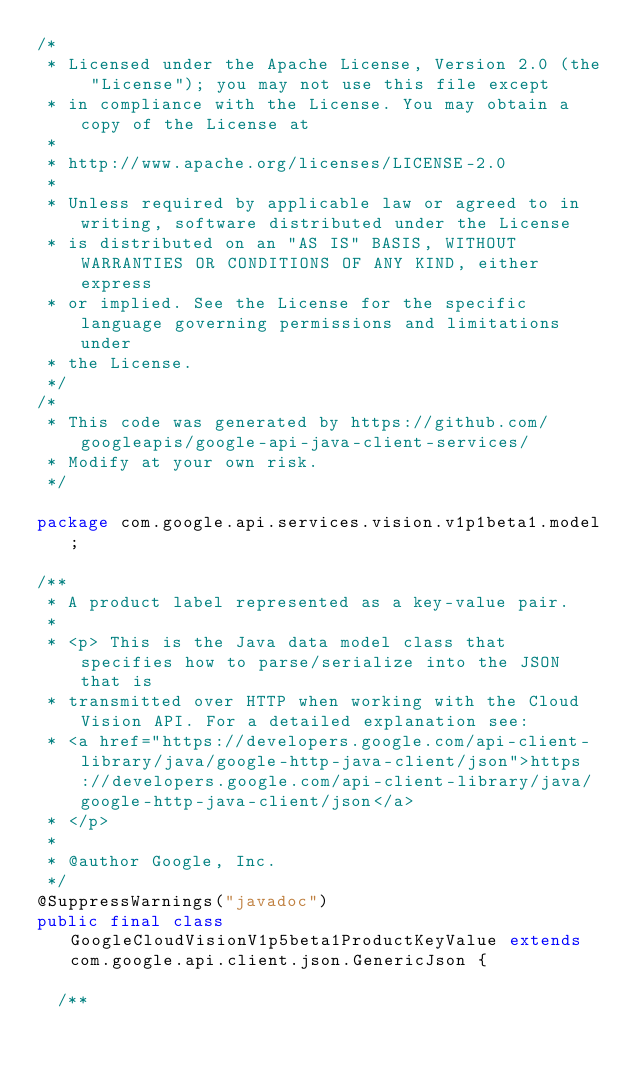Convert code to text. <code><loc_0><loc_0><loc_500><loc_500><_Java_>/*
 * Licensed under the Apache License, Version 2.0 (the "License"); you may not use this file except
 * in compliance with the License. You may obtain a copy of the License at
 *
 * http://www.apache.org/licenses/LICENSE-2.0
 *
 * Unless required by applicable law or agreed to in writing, software distributed under the License
 * is distributed on an "AS IS" BASIS, WITHOUT WARRANTIES OR CONDITIONS OF ANY KIND, either express
 * or implied. See the License for the specific language governing permissions and limitations under
 * the License.
 */
/*
 * This code was generated by https://github.com/googleapis/google-api-java-client-services/
 * Modify at your own risk.
 */

package com.google.api.services.vision.v1p1beta1.model;

/**
 * A product label represented as a key-value pair.
 *
 * <p> This is the Java data model class that specifies how to parse/serialize into the JSON that is
 * transmitted over HTTP when working with the Cloud Vision API. For a detailed explanation see:
 * <a href="https://developers.google.com/api-client-library/java/google-http-java-client/json">https://developers.google.com/api-client-library/java/google-http-java-client/json</a>
 * </p>
 *
 * @author Google, Inc.
 */
@SuppressWarnings("javadoc")
public final class GoogleCloudVisionV1p5beta1ProductKeyValue extends com.google.api.client.json.GenericJson {

  /**</code> 